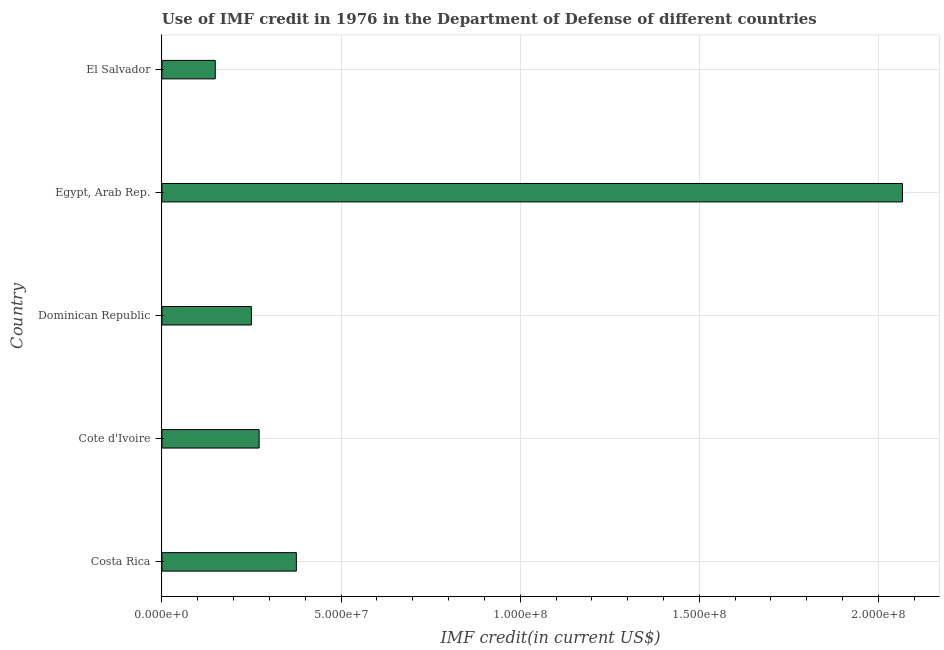Does the graph contain any zero values?
Provide a succinct answer. No. Does the graph contain grids?
Ensure brevity in your answer.  Yes. What is the title of the graph?
Your answer should be very brief. Use of IMF credit in 1976 in the Department of Defense of different countries. What is the label or title of the X-axis?
Provide a succinct answer. IMF credit(in current US$). What is the use of imf credit in dod in Costa Rica?
Make the answer very short. 3.75e+07. Across all countries, what is the maximum use of imf credit in dod?
Provide a succinct answer. 2.07e+08. Across all countries, what is the minimum use of imf credit in dod?
Ensure brevity in your answer.  1.49e+07. In which country was the use of imf credit in dod maximum?
Provide a short and direct response. Egypt, Arab Rep. In which country was the use of imf credit in dod minimum?
Keep it short and to the point. El Salvador. What is the sum of the use of imf credit in dod?
Your answer should be compact. 3.11e+08. What is the difference between the use of imf credit in dod in Cote d'Ivoire and Dominican Republic?
Your response must be concise. 2.16e+06. What is the average use of imf credit in dod per country?
Offer a very short reply. 6.22e+07. What is the median use of imf credit in dod?
Offer a very short reply. 2.71e+07. In how many countries, is the use of imf credit in dod greater than 130000000 US$?
Offer a terse response. 1. What is the ratio of the use of imf credit in dod in Cote d'Ivoire to that in Dominican Republic?
Keep it short and to the point. 1.09. Is the difference between the use of imf credit in dod in Dominican Republic and El Salvador greater than the difference between any two countries?
Keep it short and to the point. No. What is the difference between the highest and the second highest use of imf credit in dod?
Your answer should be compact. 1.69e+08. Is the sum of the use of imf credit in dod in Dominican Republic and El Salvador greater than the maximum use of imf credit in dod across all countries?
Your answer should be very brief. No. What is the difference between the highest and the lowest use of imf credit in dod?
Keep it short and to the point. 1.92e+08. In how many countries, is the use of imf credit in dod greater than the average use of imf credit in dod taken over all countries?
Provide a succinct answer. 1. How many bars are there?
Provide a succinct answer. 5. What is the difference between two consecutive major ticks on the X-axis?
Provide a succinct answer. 5.00e+07. Are the values on the major ticks of X-axis written in scientific E-notation?
Give a very brief answer. Yes. What is the IMF credit(in current US$) in Costa Rica?
Your response must be concise. 3.75e+07. What is the IMF credit(in current US$) of Cote d'Ivoire?
Provide a succinct answer. 2.71e+07. What is the IMF credit(in current US$) of Dominican Republic?
Make the answer very short. 2.50e+07. What is the IMF credit(in current US$) of Egypt, Arab Rep.?
Make the answer very short. 2.07e+08. What is the IMF credit(in current US$) of El Salvador?
Ensure brevity in your answer.  1.49e+07. What is the difference between the IMF credit(in current US$) in Costa Rica and Cote d'Ivoire?
Ensure brevity in your answer.  1.04e+07. What is the difference between the IMF credit(in current US$) in Costa Rica and Dominican Republic?
Offer a very short reply. 1.25e+07. What is the difference between the IMF credit(in current US$) in Costa Rica and Egypt, Arab Rep.?
Make the answer very short. -1.69e+08. What is the difference between the IMF credit(in current US$) in Costa Rica and El Salvador?
Your answer should be compact. 2.26e+07. What is the difference between the IMF credit(in current US$) in Cote d'Ivoire and Dominican Republic?
Give a very brief answer. 2.16e+06. What is the difference between the IMF credit(in current US$) in Cote d'Ivoire and Egypt, Arab Rep.?
Make the answer very short. -1.80e+08. What is the difference between the IMF credit(in current US$) in Cote d'Ivoire and El Salvador?
Keep it short and to the point. 1.22e+07. What is the difference between the IMF credit(in current US$) in Dominican Republic and Egypt, Arab Rep.?
Make the answer very short. -1.82e+08. What is the difference between the IMF credit(in current US$) in Dominican Republic and El Salvador?
Provide a succinct answer. 1.01e+07. What is the difference between the IMF credit(in current US$) in Egypt, Arab Rep. and El Salvador?
Offer a very short reply. 1.92e+08. What is the ratio of the IMF credit(in current US$) in Costa Rica to that in Cote d'Ivoire?
Provide a succinct answer. 1.38. What is the ratio of the IMF credit(in current US$) in Costa Rica to that in Dominican Republic?
Offer a very short reply. 1.5. What is the ratio of the IMF credit(in current US$) in Costa Rica to that in Egypt, Arab Rep.?
Make the answer very short. 0.18. What is the ratio of the IMF credit(in current US$) in Costa Rica to that in El Salvador?
Provide a succinct answer. 2.52. What is the ratio of the IMF credit(in current US$) in Cote d'Ivoire to that in Dominican Republic?
Offer a terse response. 1.09. What is the ratio of the IMF credit(in current US$) in Cote d'Ivoire to that in Egypt, Arab Rep.?
Keep it short and to the point. 0.13. What is the ratio of the IMF credit(in current US$) in Cote d'Ivoire to that in El Salvador?
Give a very brief answer. 1.82. What is the ratio of the IMF credit(in current US$) in Dominican Republic to that in Egypt, Arab Rep.?
Give a very brief answer. 0.12. What is the ratio of the IMF credit(in current US$) in Dominican Republic to that in El Salvador?
Your answer should be compact. 1.68. What is the ratio of the IMF credit(in current US$) in Egypt, Arab Rep. to that in El Salvador?
Provide a short and direct response. 13.88. 